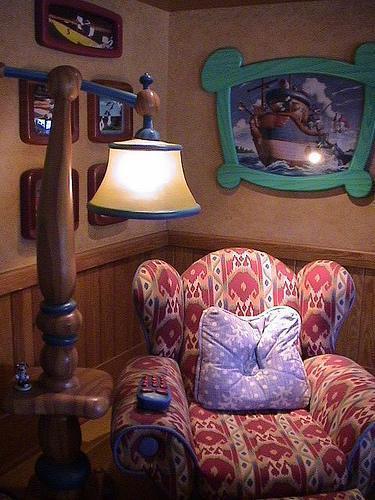How many pillows?
Give a very brief answer. 1. 